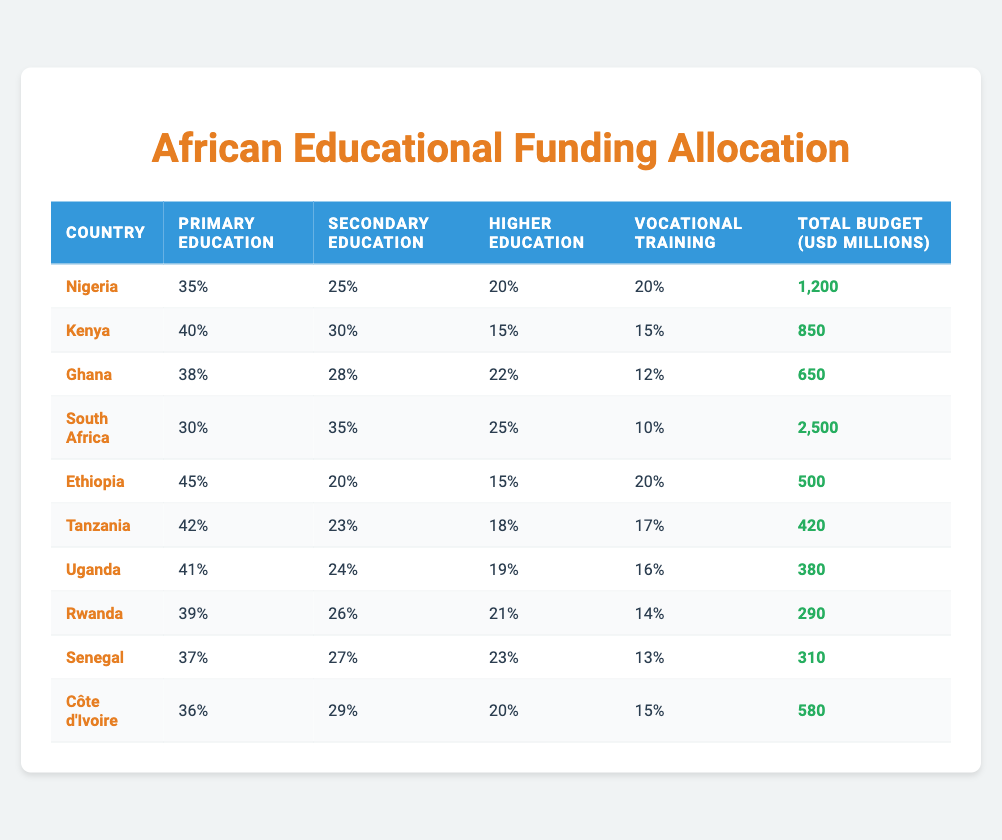What percentage of the total budget is allocated to primary education in Kenya? In the table, the percentage allocated to primary education in Kenya is listed as 40%.
Answer: 40% Which country has the highest total budget for educational programs? The table shows that South Africa has the highest total budget, which is 2500 million USD.
Answer: South Africa What is the difference in the total budget between Nigeria and Uganda? The total budget for Nigeria is 1200 million USD, while for Uganda it is 380 million USD. The difference is calculated by subtracting Uganda's total from Nigeria's: 1200 - 380 = 820 million USD.
Answer: 820 million USD Does Ethiopia allocate more to primary education than Uganda? Ethiopia allocates 45% to primary education, while Uganda allocates 41%. Since 45% is greater than 41%, the answer is yes.
Answer: Yes Which two countries allocate more to secondary education than the average percentage of secondary education across all countries listed? To find the average percentage of secondary education, we need to sum the secondary education percentages: (25 + 30 + 28 + 35 + 20 + 23 + 24 + 26 + 27 + 29) / 10 = 25.7%. The countries that allocate more than this are South Africa (35%) and Kenya (30%).
Answer: South Africa and Kenya How much total budget does Ghana have for vocational training? In the table, Ghana's total budget allocated to vocational training is shown as 12%.
Answer: 12% If we combine the primary education allocations of Nigeria and Kenya, what is the total percentage? The primary education allocations are 35% for Nigeria and 40% for Kenya. The total percentage is found by adding these together: 35% + 40% = 75%.
Answer: 75% Which country has the smallest total budget for educational programs? The table indicates that Rwanda has the smallest total budget at 290 million USD.
Answer: Rwanda Is Côte d'Ivoire's allocation for higher education higher than that of Ethiopia? Côte d'Ivoire allocates 20% to higher education, while Ethiopia allocates 15%. Since 20% is higher than 15%, the answer is yes.
Answer: Yes 